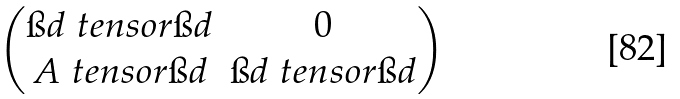Convert formula to latex. <formula><loc_0><loc_0><loc_500><loc_500>\begin{pmatrix} \i d \ t e n s o r \i d & 0 \\ A \ t e n s o r \i d & \i d \ t e n s o r \i d \end{pmatrix}</formula> 